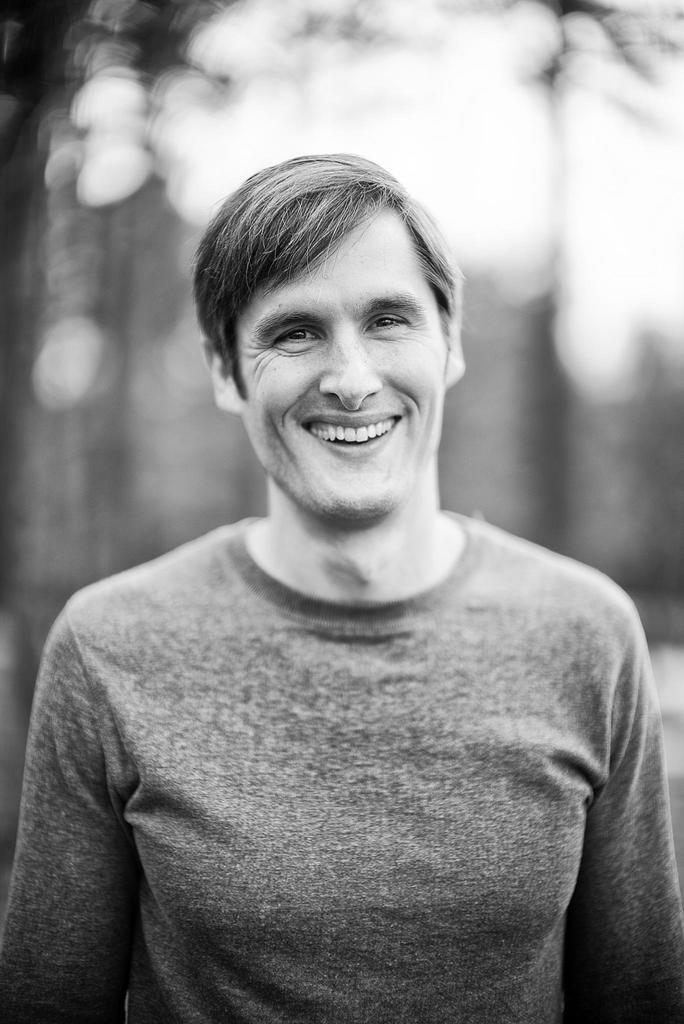What is the main subject of the image? There is a person in the image. What is the person's expression in the image? The person is smiling in the image. How would you describe the background of the image? The background of the image is blurry. What type of religious symbol can be seen in the image? There is no religious symbol present in the image. Is there a tramp visible in the image? There is no tramp present in the image. 